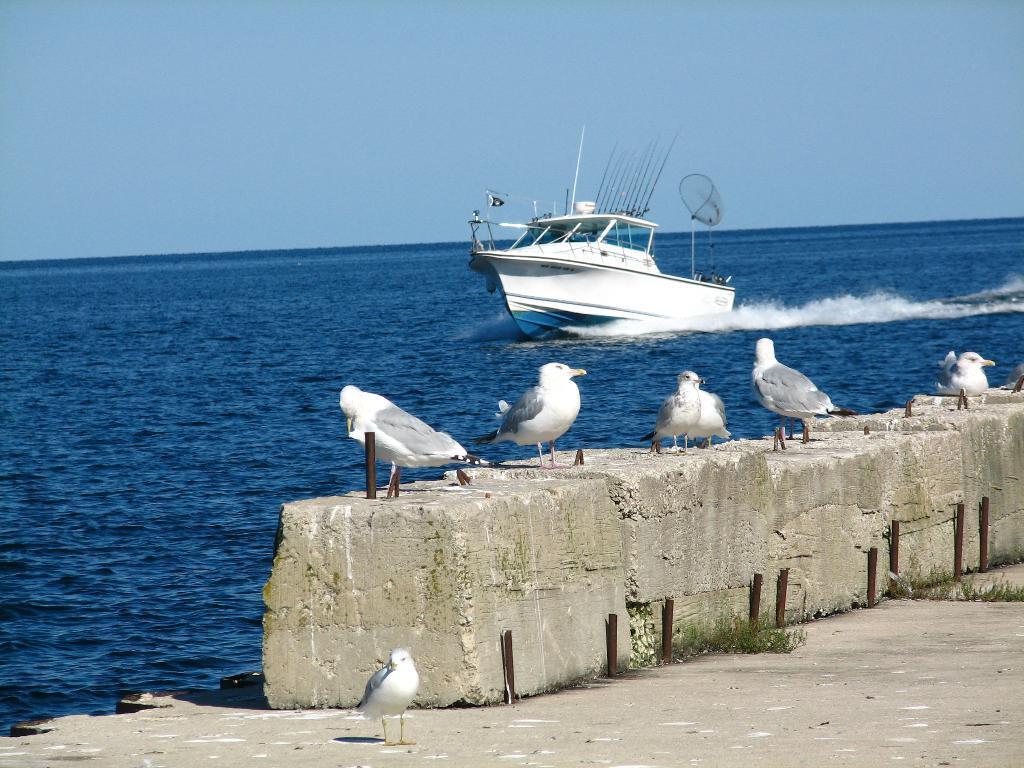Describe this image in one or two sentences. In this picture I can see a boat in the water and I can see few birds on the ground and I can see a cloudy sky. 